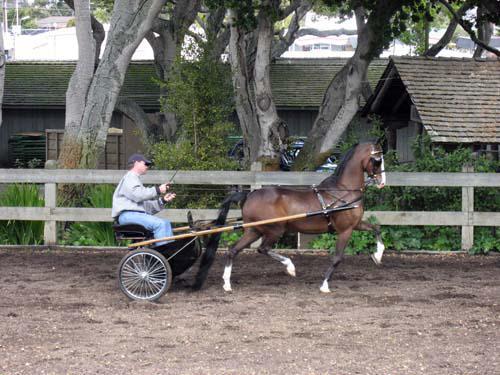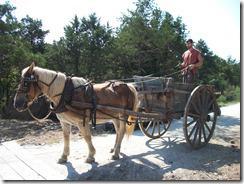The first image is the image on the left, the second image is the image on the right. Evaluate the accuracy of this statement regarding the images: "At least one image shows a cart that is not hooked up to a horse.". Is it true? Answer yes or no. No. The first image is the image on the left, the second image is the image on the right. Given the left and right images, does the statement "There is a person in the image on the right." hold true? Answer yes or no. Yes. 